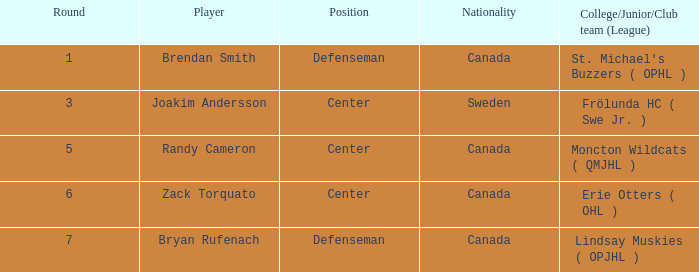What position does Zack Torquato play? Center. Can you give me this table as a dict? {'header': ['Round', 'Player', 'Position', 'Nationality', 'College/Junior/Club team (League)'], 'rows': [['1', 'Brendan Smith', 'Defenseman', 'Canada', "St. Michael's Buzzers ( OPHL )"], ['3', 'Joakim Andersson', 'Center', 'Sweden', 'Frölunda HC ( Swe Jr. )'], ['5', 'Randy Cameron', 'Center', 'Canada', 'Moncton Wildcats ( QMJHL )'], ['6', 'Zack Torquato', 'Center', 'Canada', 'Erie Otters ( OHL )'], ['7', 'Bryan Rufenach', 'Defenseman', 'Canada', 'Lindsay Muskies ( OPJHL )']]} 